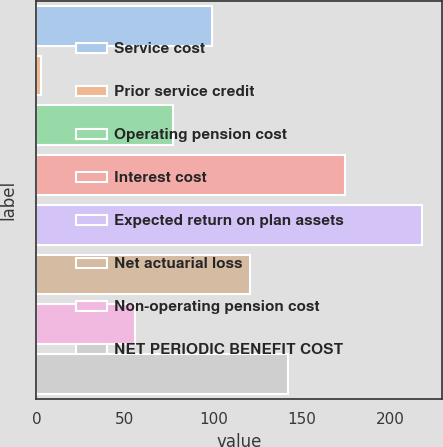Convert chart to OTSL. <chart><loc_0><loc_0><loc_500><loc_500><bar_chart><fcel>Service cost<fcel>Prior service credit<fcel>Operating pension cost<fcel>Interest cost<fcel>Expected return on plan assets<fcel>Net actuarial loss<fcel>Non-operating pension cost<fcel>NET PERIODIC BENEFIT COST<nl><fcel>98.94<fcel>2.7<fcel>77.42<fcel>174.2<fcel>217.9<fcel>120.46<fcel>55.9<fcel>141.98<nl></chart> 